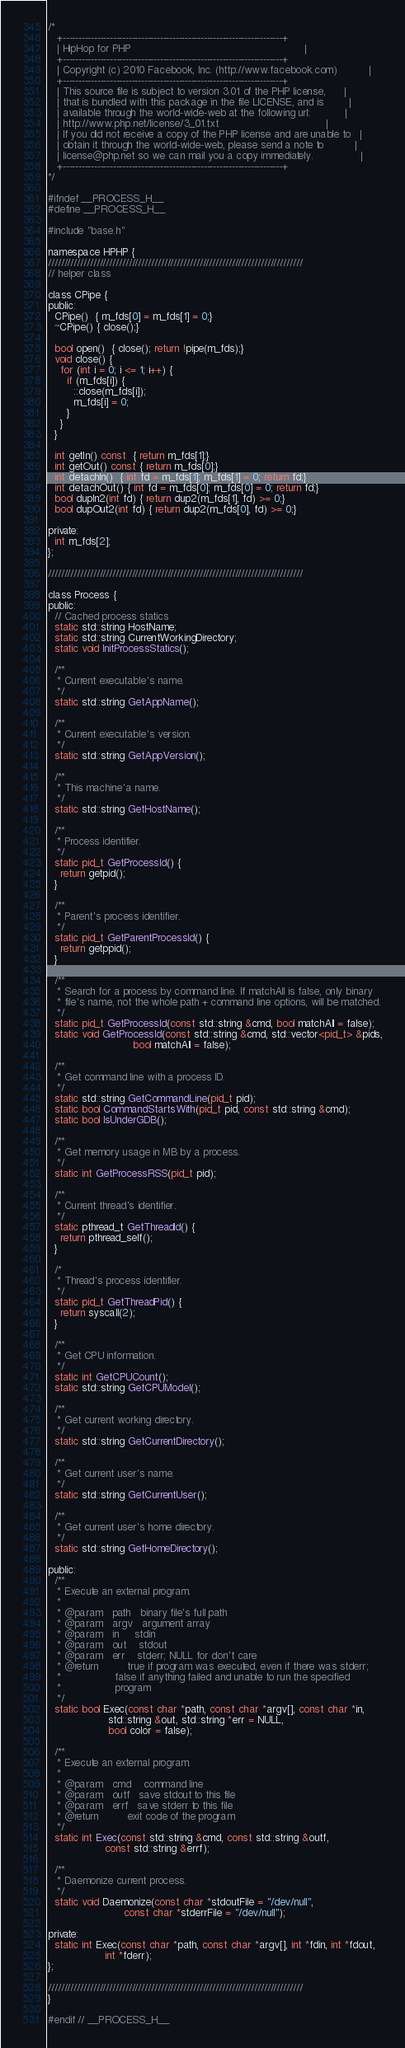Convert code to text. <code><loc_0><loc_0><loc_500><loc_500><_C_>/*
   +----------------------------------------------------------------------+
   | HipHop for PHP                                                       |
   +----------------------------------------------------------------------+
   | Copyright (c) 2010 Facebook, Inc. (http://www.facebook.com)          |
   +----------------------------------------------------------------------+
   | This source file is subject to version 3.01 of the PHP license,      |
   | that is bundled with this package in the file LICENSE, and is        |
   | available through the world-wide-web at the following url:           |
   | http://www.php.net/license/3_01.txt                                  |
   | If you did not receive a copy of the PHP license and are unable to   |
   | obtain it through the world-wide-web, please send a note to          |
   | license@php.net so we can mail you a copy immediately.               |
   +----------------------------------------------------------------------+
*/

#ifndef __PROCESS_H__
#define __PROCESS_H__

#include "base.h"

namespace HPHP {
///////////////////////////////////////////////////////////////////////////////
// helper class

class CPipe {
public:
  CPipe()  { m_fds[0] = m_fds[1] = 0;}
  ~CPipe() { close();}

  bool open()  { close(); return !pipe(m_fds);}
  void close() {
    for (int i = 0; i <= 1; i++) {
      if (m_fds[i]) {
        ::close(m_fds[i]);
        m_fds[i] = 0;
      }
    }
  }

  int getIn() const  { return m_fds[1];}
  int getOut() const { return m_fds[0];}
  int detachIn()  { int fd = m_fds[1]; m_fds[1] = 0; return fd;}
  int detachOut() { int fd = m_fds[0]; m_fds[0] = 0; return fd;}
  bool dupIn2(int fd) { return dup2(m_fds[1], fd) >= 0;}
  bool dupOut2(int fd) { return dup2(m_fds[0], fd) >= 0;}

private:
  int m_fds[2];
};

///////////////////////////////////////////////////////////////////////////////

class Process {
public:
  // Cached process statics
  static std::string HostName;
  static std::string CurrentWorkingDirectory;
  static void InitProcessStatics();

  /**
   * Current executable's name.
   */
  static std::string GetAppName();

  /**
   * Current executable's version.
   */
  static std::string GetAppVersion();

  /**
   * This machine'a name.
   */
  static std::string GetHostName();

  /**
   * Process identifier.
   */
  static pid_t GetProcessId() {
    return getpid();
  }

  /**
   * Parent's process identifier.
   */
  static pid_t GetParentProcessId() {
    return getppid();
  }

  /**
   * Search for a process by command line. If matchAll is false, only binary
   * file's name, not the whole path + command line options, will be matched.
   */
  static pid_t GetProcessId(const std::string &cmd, bool matchAll = false);
  static void GetProcessId(const std::string &cmd, std::vector<pid_t> &pids,
                           bool matchAll = false);

  /**
   * Get command line with a process ID.
   */
  static std::string GetCommandLine(pid_t pid);
  static bool CommandStartsWith(pid_t pid, const std::string &cmd);
  static bool IsUnderGDB();

  /**
   * Get memory usage in MB by a process.
   */
  static int GetProcessRSS(pid_t pid);

  /**
   * Current thread's identifier.
   */
  static pthread_t GetThreadId() {
    return pthread_self();
  }

  /*
   * Thread's process identifier.
   */
  static pid_t GetThreadPid() {
    return syscall(2);
  }

  /**
   * Get CPU information.
   */
  static int GetCPUCount();
  static std::string GetCPUModel();

  /**
   * Get current working directory.
   */
  static std::string GetCurrentDirectory();

  /**
   * Get current user's name.
   */
  static std::string GetCurrentUser();

  /**
   * Get current user's home directory.
   */
  static std::string GetHomeDirectory();

public:
  /**
   * Execute an external program.
   *
   * @param   path   binary file's full path
   * @param   argv   argument array
   * @param   in     stdin
   * @param   out    stdout
   * @param   err    stderr; NULL for don't care
   * @return         true if program was executed, even if there was stderr;
   *                 false if anything failed and unable to run the specified
   *                 program
   */
  static bool Exec(const char *path, const char *argv[], const char *in,
                   std::string &out, std::string *err = NULL,
                   bool color = false);

  /**
   * Execute an external program.
   *
   * @param   cmd    command line
   * @param   outf   save stdout to this file
   * @param   errf   save stderr to this file
   * @return         exit code of the program
   */
  static int Exec(const std::string &cmd, const std::string &outf,
                  const std::string &errf);

  /**
   * Daemonize current process.
   */
  static void Daemonize(const char *stdoutFile = "/dev/null",
                        const char *stderrFile = "/dev/null");

private:
  static int Exec(const char *path, const char *argv[], int *fdin, int *fdout,
                  int *fderr);
};

///////////////////////////////////////////////////////////////////////////////
}

#endif // __PROCESS_H__
</code> 